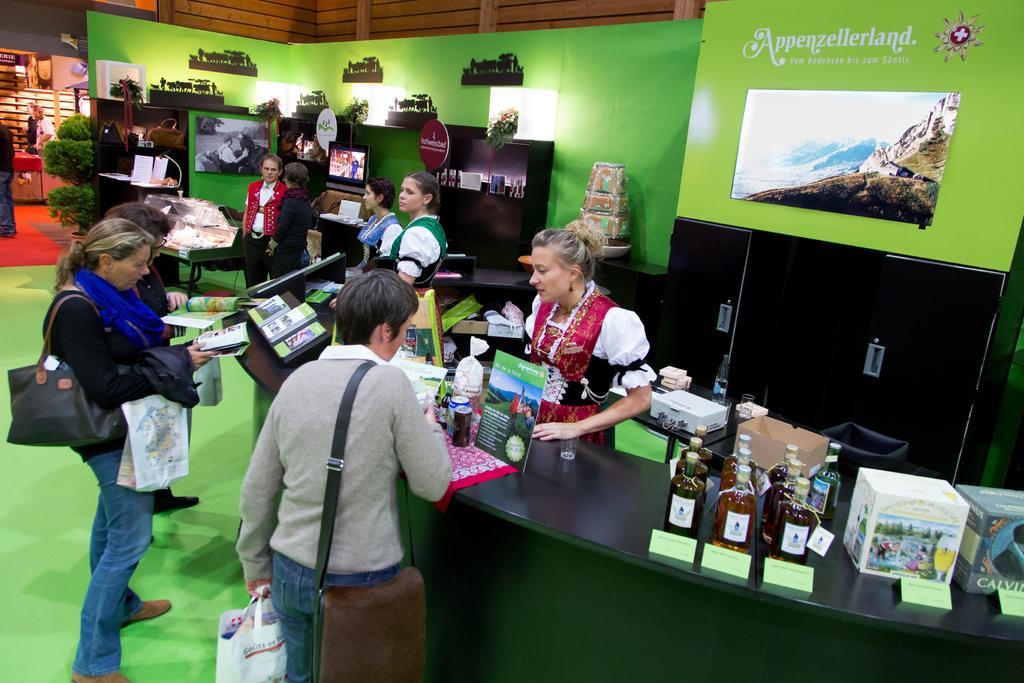Can you describe this image briefly? In the image we can see there are people who are standing on the floor and on the table there are wine bottles kept and there is one tv screen in between. 